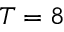Convert formula to latex. <formula><loc_0><loc_0><loc_500><loc_500>T = 8</formula> 